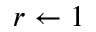Convert formula to latex. <formula><loc_0><loc_0><loc_500><loc_500>r \gets 1</formula> 